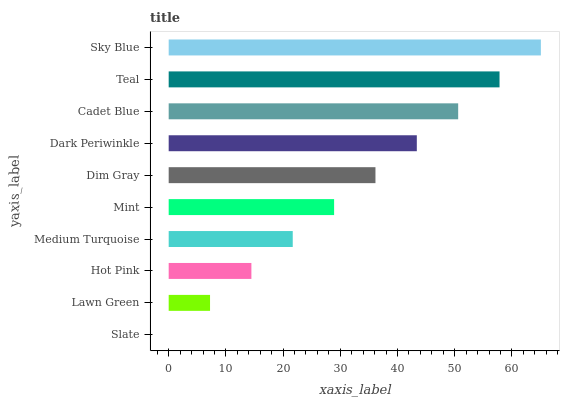Is Slate the minimum?
Answer yes or no. Yes. Is Sky Blue the maximum?
Answer yes or no. Yes. Is Lawn Green the minimum?
Answer yes or no. No. Is Lawn Green the maximum?
Answer yes or no. No. Is Lawn Green greater than Slate?
Answer yes or no. Yes. Is Slate less than Lawn Green?
Answer yes or no. Yes. Is Slate greater than Lawn Green?
Answer yes or no. No. Is Lawn Green less than Slate?
Answer yes or no. No. Is Dim Gray the high median?
Answer yes or no. Yes. Is Mint the low median?
Answer yes or no. Yes. Is Sky Blue the high median?
Answer yes or no. No. Is Cadet Blue the low median?
Answer yes or no. No. 